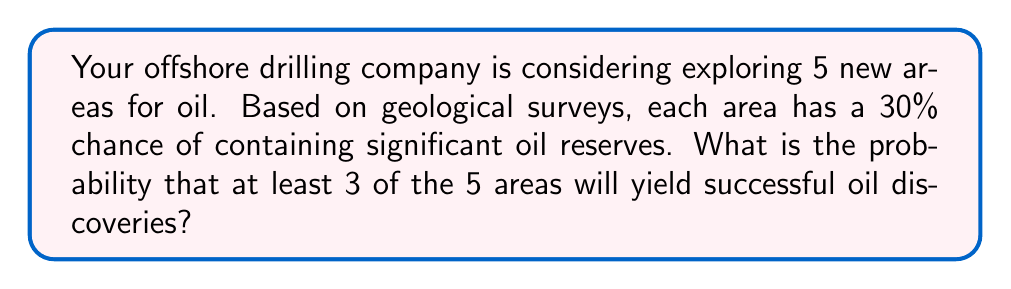Teach me how to tackle this problem. Let's approach this step-by-step using the binomial probability distribution:

1) We can model this scenario as a binomial distribution with:
   $n = 5$ (number of areas)
   $p = 0.30$ (probability of success for each area)
   $X$ = number of successful discoveries

2) We need to find $P(X \geq 3)$, which is equivalent to:
   $P(X = 3) + P(X = 4) + P(X = 5)$

3) The binomial probability formula is:
   $$P(X = k) = \binom{n}{k} p^k (1-p)^{n-k}$$

4) Let's calculate each probability:

   For $k = 3$:
   $$P(X = 3) = \binom{5}{3} (0.30)^3 (0.70)^2 = 10 \cdot 0.027 \cdot 0.49 = 0.1323$$

   For $k = 4$:
   $$P(X = 4) = \binom{5}{4} (0.30)^4 (0.70)^1 = 5 \cdot 0.0081 \cdot 0.70 = 0.02835$$

   For $k = 5$:
   $$P(X = 5) = \binom{5}{5} (0.30)^5 (0.70)^0 = 1 \cdot 0.00243 \cdot 1 = 0.00243$$

5) Sum these probabilities:
   $P(X \geq 3) = 0.1323 + 0.02835 + 0.00243 = 0.16308$

6) Convert to a percentage:
   $0.16308 \cdot 100\% = 16.308\%$
Answer: 16.31% 